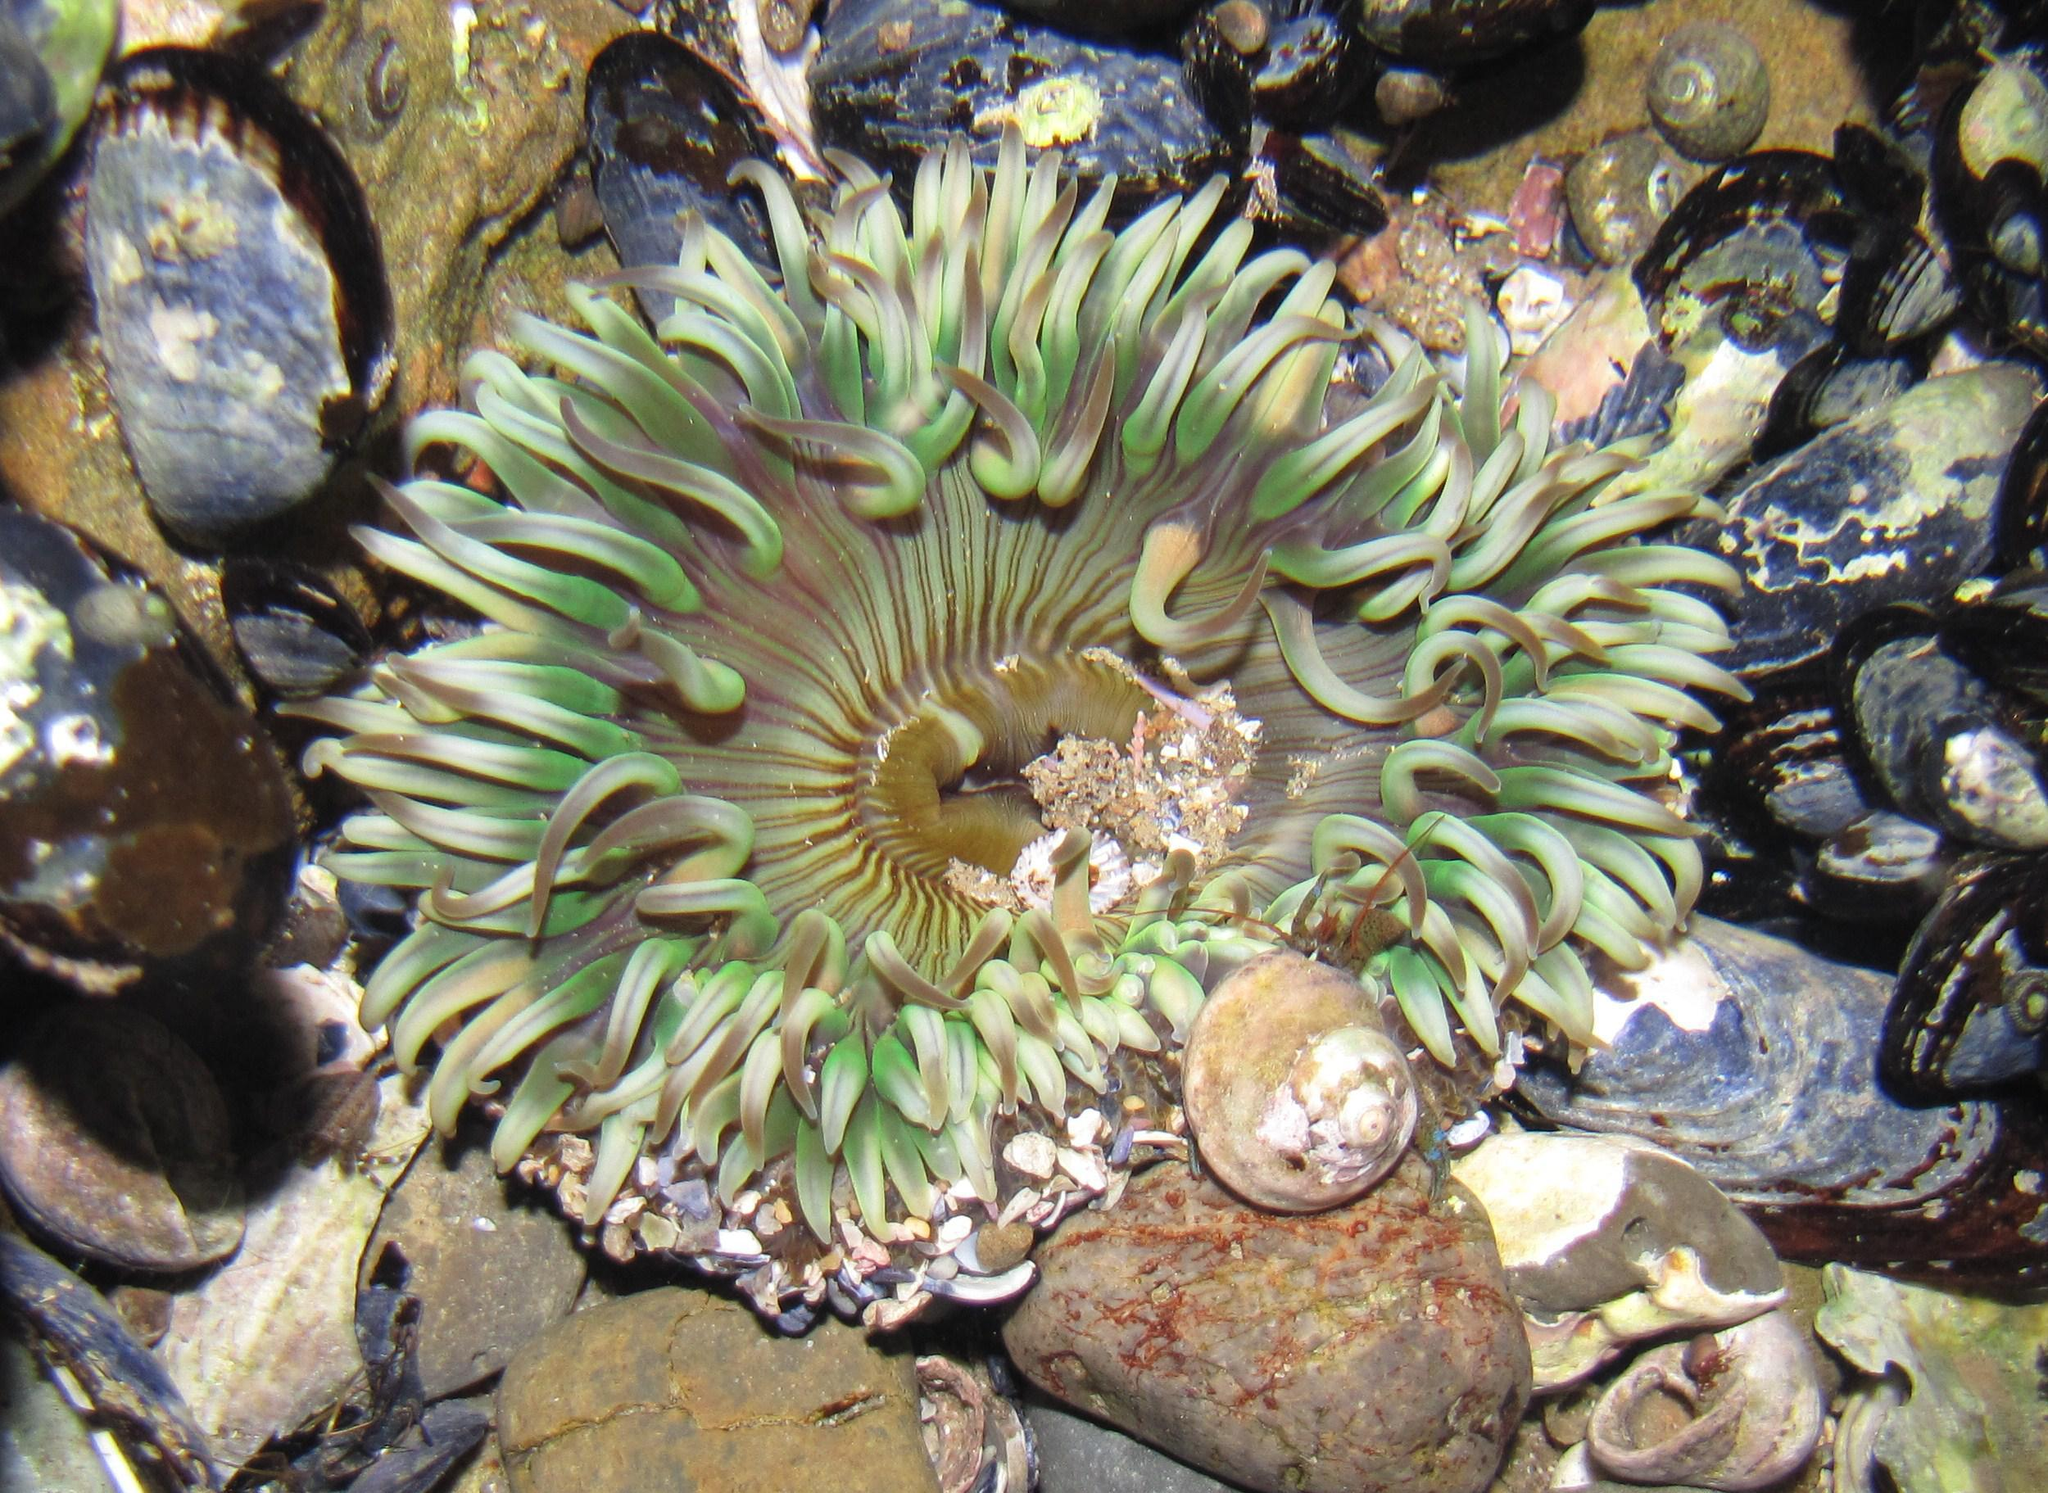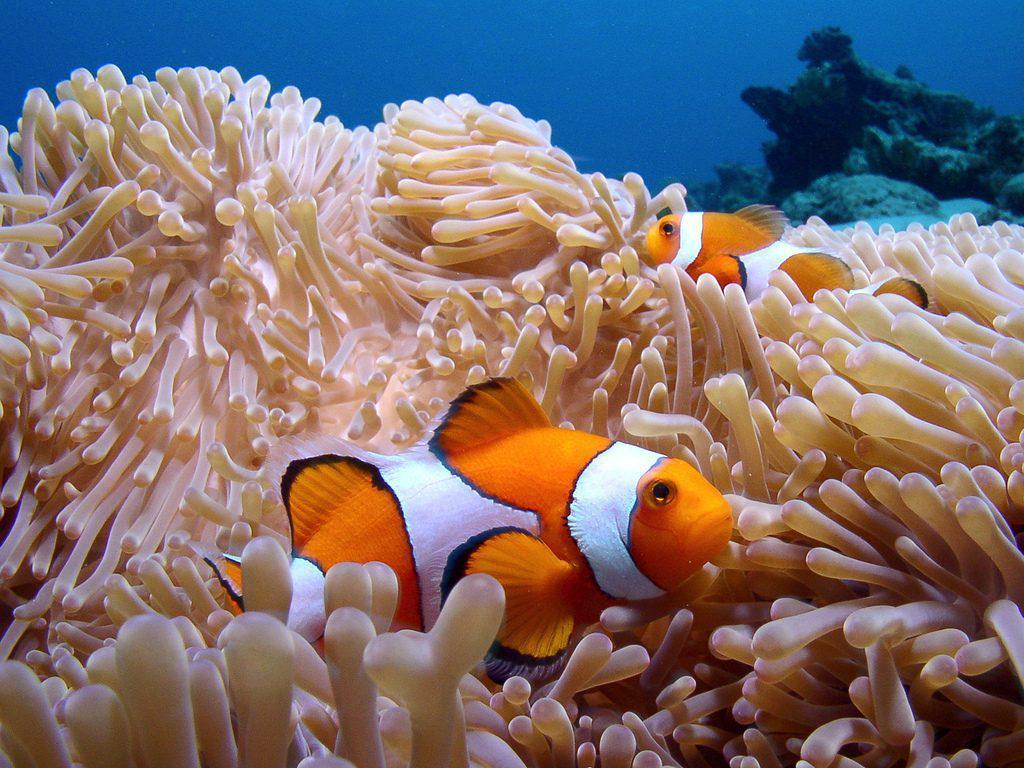The first image is the image on the left, the second image is the image on the right. Assess this claim about the two images: "The left image shows exactly two clown fish close together over anemone, and the right image includes a clown fish over white anemone tendrils.". Correct or not? Answer yes or no. No. The first image is the image on the left, the second image is the image on the right. For the images shown, is this caption "The left and right image contains the same number of fish." true? Answer yes or no. No. 